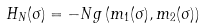<formula> <loc_0><loc_0><loc_500><loc_500>H _ { N } ( \sigma ) = - N g \left ( m _ { 1 } ( \sigma ) , m _ { 2 } ( \sigma ) \right )</formula> 